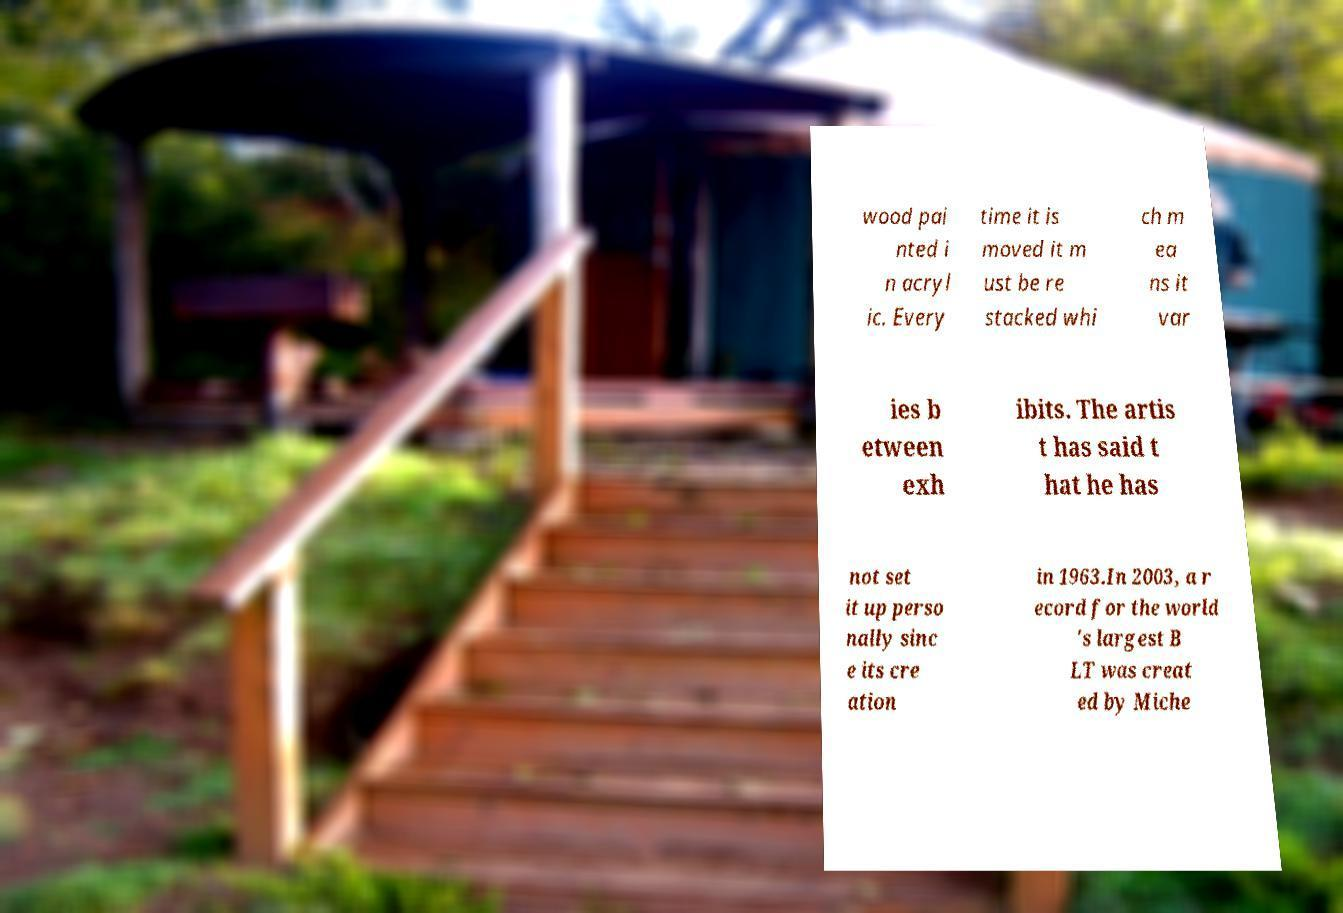Can you accurately transcribe the text from the provided image for me? wood pai nted i n acryl ic. Every time it is moved it m ust be re stacked whi ch m ea ns it var ies b etween exh ibits. The artis t has said t hat he has not set it up perso nally sinc e its cre ation in 1963.In 2003, a r ecord for the world 's largest B LT was creat ed by Miche 